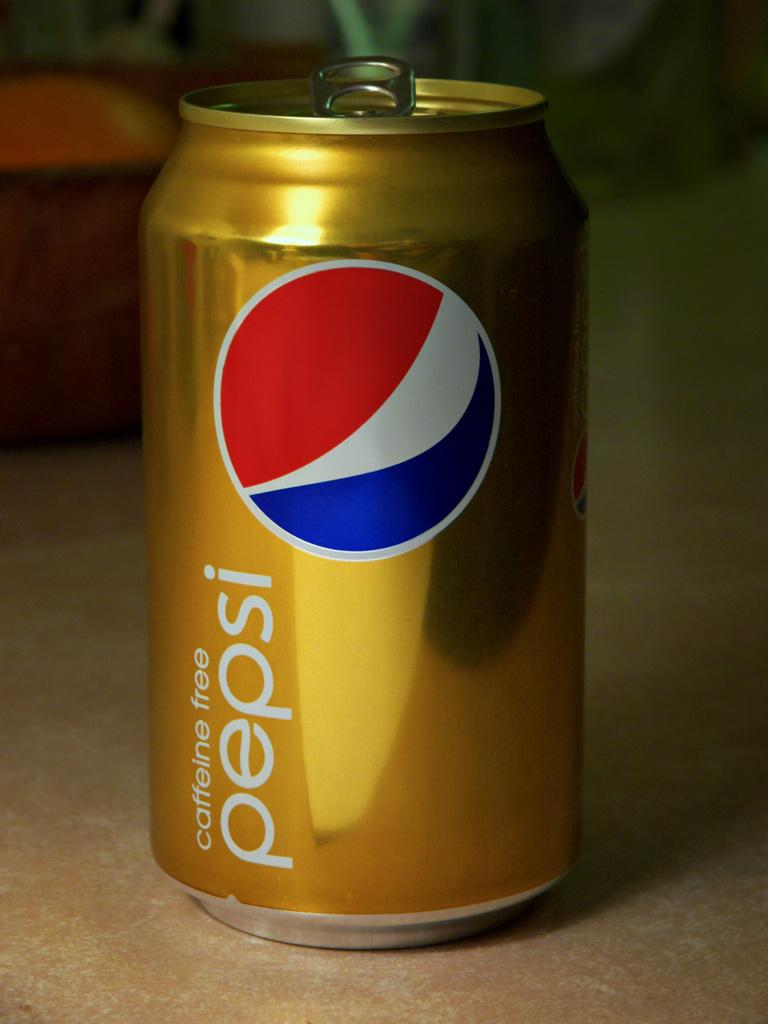Provide a one-sentence caption for the provided image. Gold Pepsi Can that is Caffeine Free and is open from the lid. 